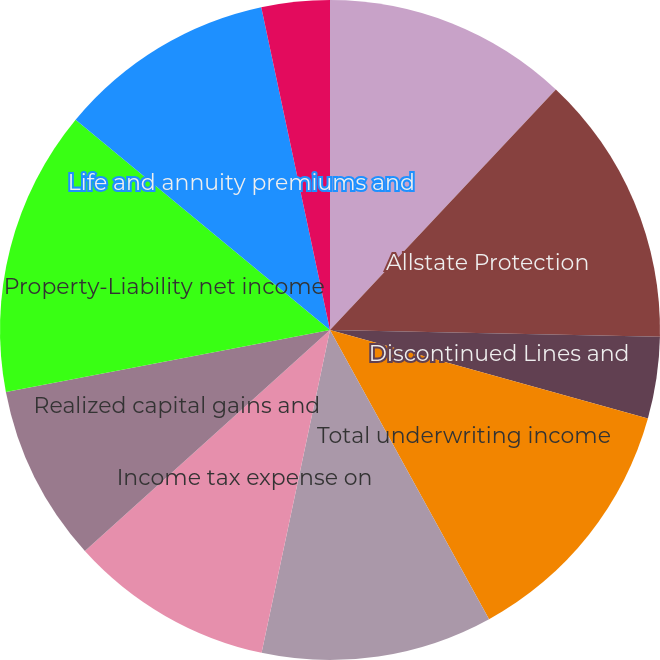Convert chart to OTSL. <chart><loc_0><loc_0><loc_500><loc_500><pie_chart><fcel>( in millions)<fcel>Allstate Protection<fcel>Discontinued Lines and<fcel>Total underwriting income<fcel>Net investment income<fcel>Income tax expense on<fcel>Realized capital gains and<fcel>Property-Liability net income<fcel>Life and annuity premiums and<fcel>Periodic settlements and<nl><fcel>12.0%<fcel>13.33%<fcel>4.0%<fcel>12.67%<fcel>11.33%<fcel>10.0%<fcel>8.67%<fcel>14.0%<fcel>10.67%<fcel>3.34%<nl></chart> 